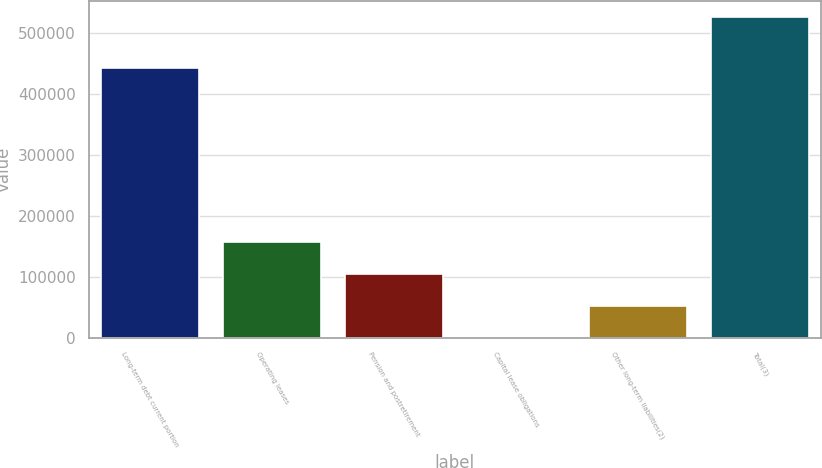Convert chart. <chart><loc_0><loc_0><loc_500><loc_500><bar_chart><fcel>Long-term debt current portion<fcel>Operating leases<fcel>Pension and postretirement<fcel>Capital lease obligations<fcel>Other long-term liabilities(2)<fcel>Total(3)<nl><fcel>442083<fcel>157970<fcel>105404<fcel>273<fcel>52838.7<fcel>525930<nl></chart> 